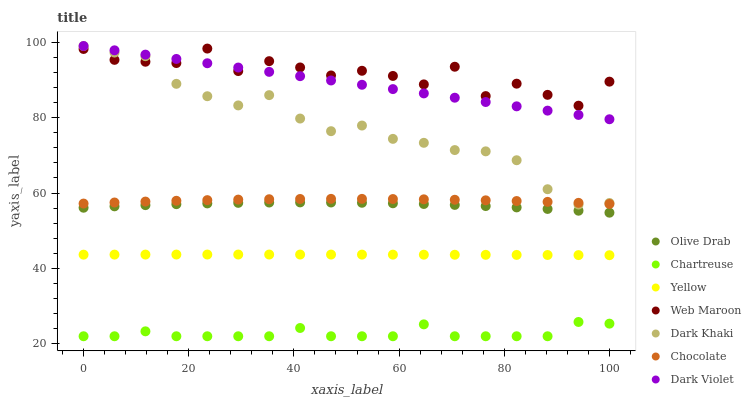Does Chartreuse have the minimum area under the curve?
Answer yes or no. Yes. Does Web Maroon have the maximum area under the curve?
Answer yes or no. Yes. Does Yellow have the minimum area under the curve?
Answer yes or no. No. Does Yellow have the maximum area under the curve?
Answer yes or no. No. Is Dark Violet the smoothest?
Answer yes or no. Yes. Is Web Maroon the roughest?
Answer yes or no. Yes. Is Yellow the smoothest?
Answer yes or no. No. Is Yellow the roughest?
Answer yes or no. No. Does Chartreuse have the lowest value?
Answer yes or no. Yes. Does Yellow have the lowest value?
Answer yes or no. No. Does Dark Violet have the highest value?
Answer yes or no. Yes. Does Yellow have the highest value?
Answer yes or no. No. Is Yellow less than Web Maroon?
Answer yes or no. Yes. Is Web Maroon greater than Yellow?
Answer yes or no. Yes. Does Dark Violet intersect Web Maroon?
Answer yes or no. Yes. Is Dark Violet less than Web Maroon?
Answer yes or no. No. Is Dark Violet greater than Web Maroon?
Answer yes or no. No. Does Yellow intersect Web Maroon?
Answer yes or no. No. 